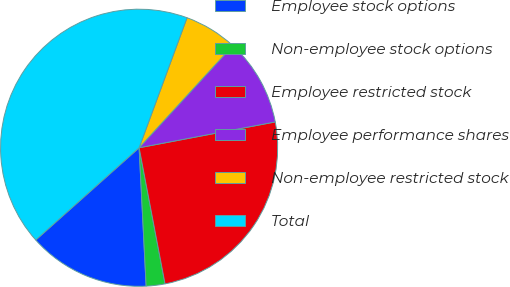Convert chart to OTSL. <chart><loc_0><loc_0><loc_500><loc_500><pie_chart><fcel>Employee stock options<fcel>Non-employee stock options<fcel>Employee restricted stock<fcel>Employee performance shares<fcel>Non-employee restricted stock<fcel>Total<nl><fcel>14.21%<fcel>2.19%<fcel>24.99%<fcel>10.2%<fcel>6.2%<fcel>42.22%<nl></chart> 